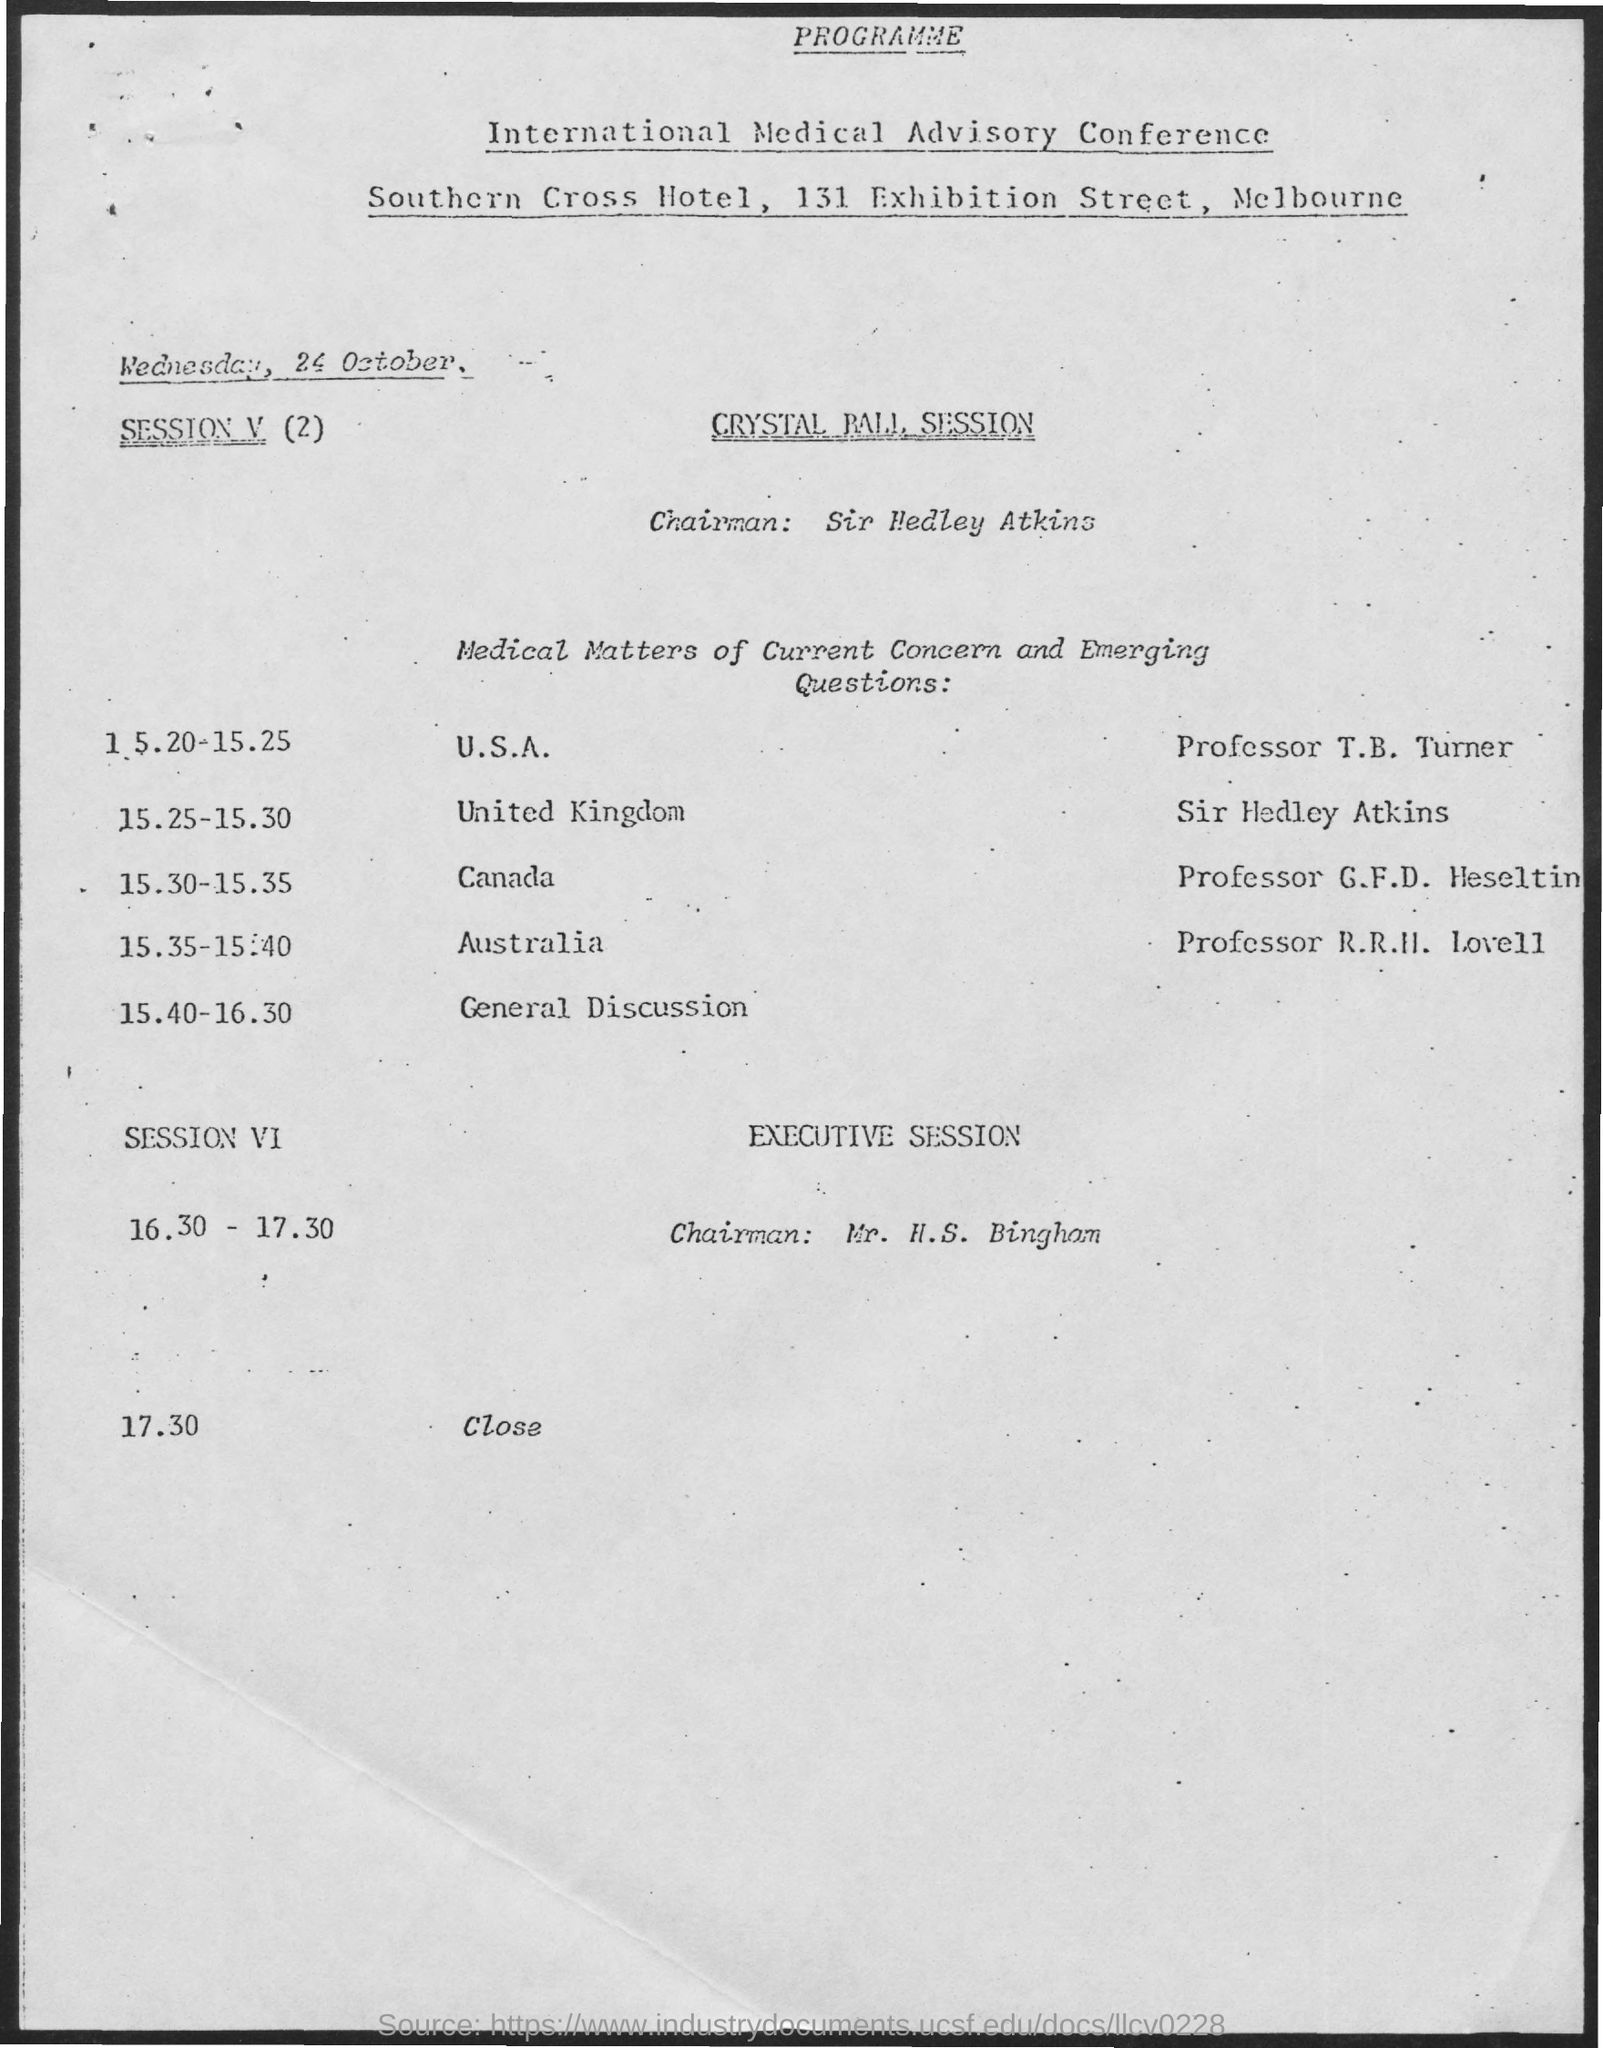What is the date mentioned ?
Keep it short and to the point. Wednesday . 24 , october. Who is the chairman of crystal pall session ?
Your response must be concise. Sir Hedley Atkins. At 15.25 - 15:30 the session is taken  by whom ?
Your response must be concise. Sir Hedley Atkins. At what time the session is closed ?
Keep it short and to the point. 17:30. What is the venue for the sir hedley atkins session ?
Make the answer very short. United Kingdom. 